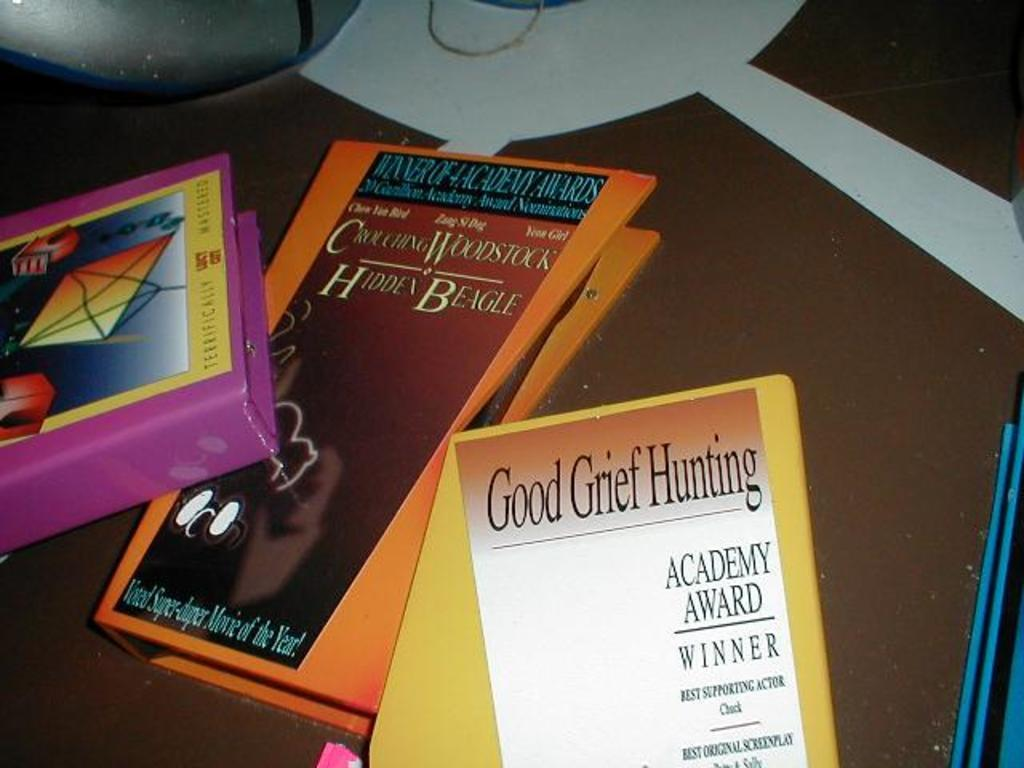<image>
Describe the image concisely. Good Grief Hunting is the title of a book on a table with others. 